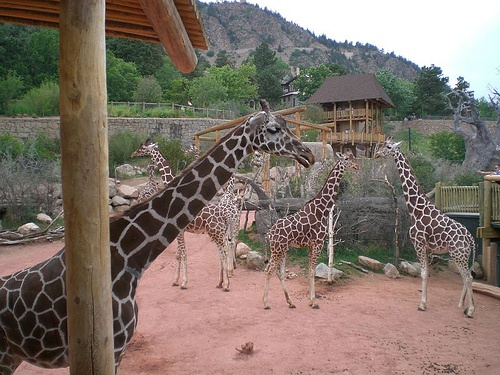Describe the objects in this image and their specific colors. I can see giraffe in maroon, black, gray, and darkgray tones, giraffe in maroon, gray, and darkgray tones, giraffe in maroon, gray, darkgray, and black tones, giraffe in maroon, lightpink, gray, darkgray, and brown tones, and giraffe in maroon, darkgray, gray, and lightgray tones in this image. 